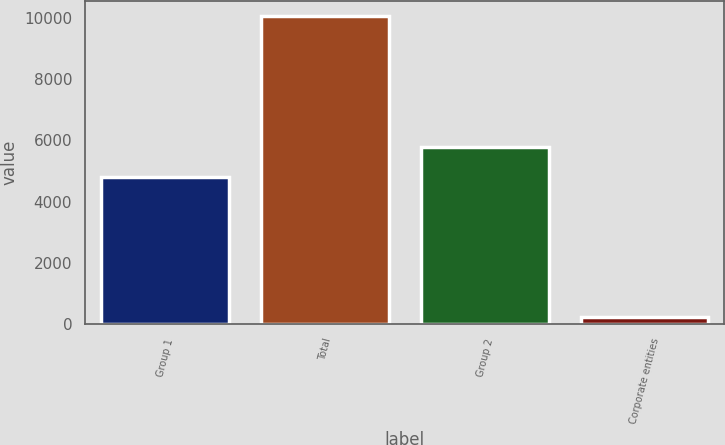Convert chart. <chart><loc_0><loc_0><loc_500><loc_500><bar_chart><fcel>Group 1<fcel>Total<fcel>Group 2<fcel>Corporate entities<nl><fcel>4811.9<fcel>10040.9<fcel>5791.11<fcel>248.8<nl></chart> 